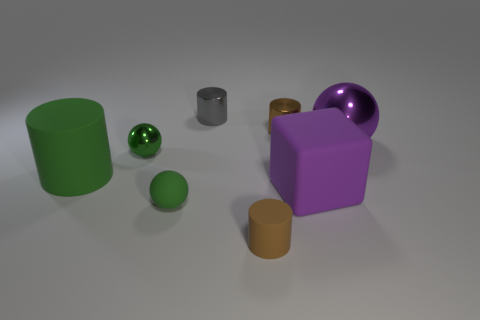What is the material of the purple cube that is the same size as the green matte cylinder?
Your response must be concise. Rubber. What material is the sphere that is the same color as the big rubber cube?
Offer a very short reply. Metal. There is another tiny green object that is the same shape as the green metal thing; what material is it?
Your answer should be very brief. Rubber. There is a small brown thing behind the big purple rubber block; what shape is it?
Your response must be concise. Cylinder. What number of other things are there of the same shape as the small gray thing?
Ensure brevity in your answer.  3. Is the brown cylinder that is in front of the purple shiny thing made of the same material as the large purple sphere?
Your answer should be very brief. No. Are there the same number of tiny rubber objects on the left side of the green matte sphere and metallic things that are to the left of the small brown metallic cylinder?
Make the answer very short. No. There is a matte cylinder right of the tiny gray metal object; what is its size?
Keep it short and to the point. Small. Are there any big objects that have the same material as the large purple sphere?
Your response must be concise. No. There is a big object on the right side of the big purple cube; is it the same color as the big rubber cylinder?
Make the answer very short. No. 